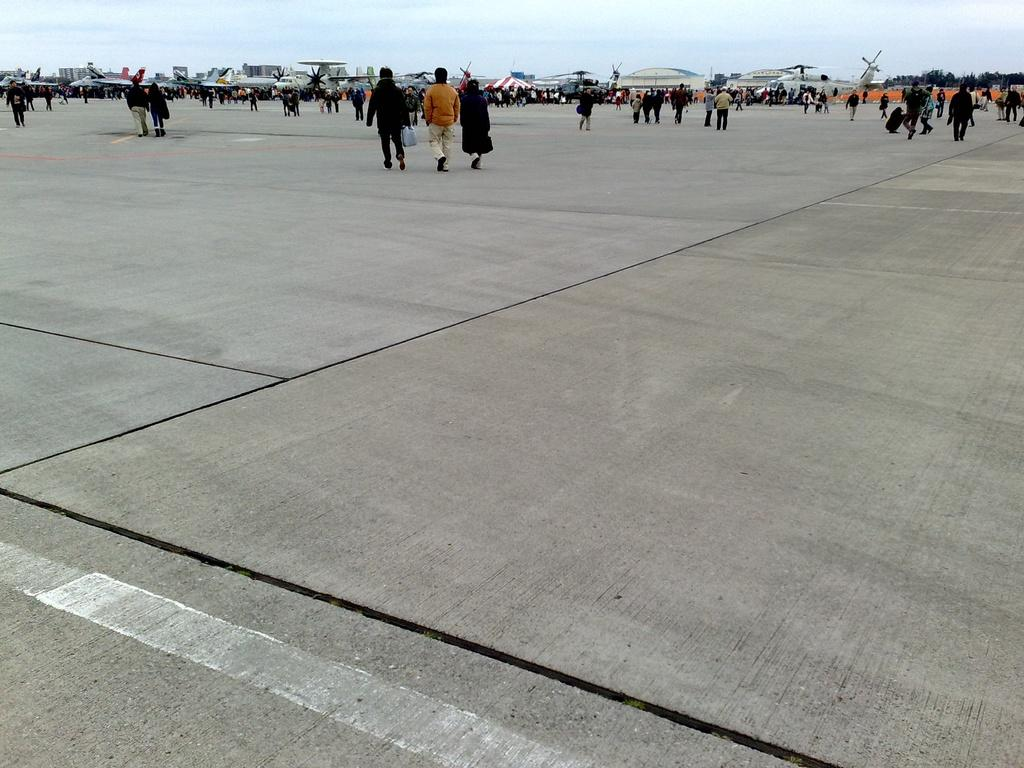What type of location is depicted in the image? The image is an inside view of an airport. What can be seen in the image besides the airport setting? There is an aeroplane in the image. How many people are visible in the image? There are many people in the image. What scent can be detected in the image? There is no information about the scent in the image, as it is a visual medium. 